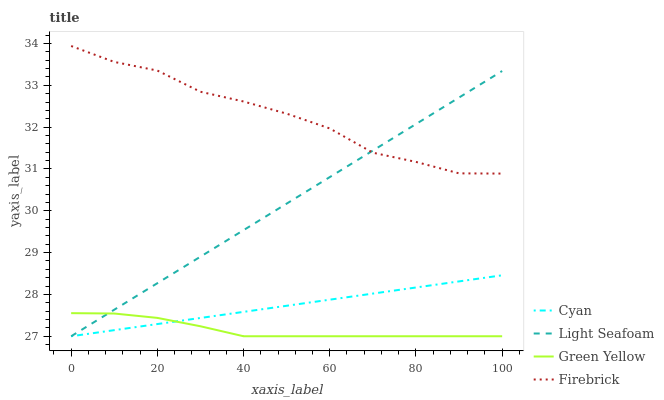Does Green Yellow have the minimum area under the curve?
Answer yes or no. Yes. Does Firebrick have the maximum area under the curve?
Answer yes or no. Yes. Does Light Seafoam have the minimum area under the curve?
Answer yes or no. No. Does Light Seafoam have the maximum area under the curve?
Answer yes or no. No. Is Light Seafoam the smoothest?
Answer yes or no. Yes. Is Firebrick the roughest?
Answer yes or no. Yes. Is Green Yellow the smoothest?
Answer yes or no. No. Is Green Yellow the roughest?
Answer yes or no. No. Does Cyan have the lowest value?
Answer yes or no. Yes. Does Firebrick have the lowest value?
Answer yes or no. No. Does Firebrick have the highest value?
Answer yes or no. Yes. Does Light Seafoam have the highest value?
Answer yes or no. No. Is Green Yellow less than Firebrick?
Answer yes or no. Yes. Is Firebrick greater than Cyan?
Answer yes or no. Yes. Does Green Yellow intersect Cyan?
Answer yes or no. Yes. Is Green Yellow less than Cyan?
Answer yes or no. No. Is Green Yellow greater than Cyan?
Answer yes or no. No. Does Green Yellow intersect Firebrick?
Answer yes or no. No. 